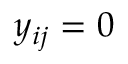Convert formula to latex. <formula><loc_0><loc_0><loc_500><loc_500>y _ { i j } = 0</formula> 